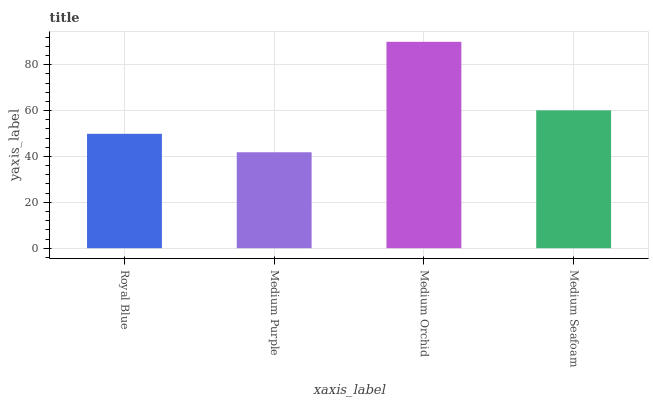Is Medium Purple the minimum?
Answer yes or no. Yes. Is Medium Orchid the maximum?
Answer yes or no. Yes. Is Medium Orchid the minimum?
Answer yes or no. No. Is Medium Purple the maximum?
Answer yes or no. No. Is Medium Orchid greater than Medium Purple?
Answer yes or no. Yes. Is Medium Purple less than Medium Orchid?
Answer yes or no. Yes. Is Medium Purple greater than Medium Orchid?
Answer yes or no. No. Is Medium Orchid less than Medium Purple?
Answer yes or no. No. Is Medium Seafoam the high median?
Answer yes or no. Yes. Is Royal Blue the low median?
Answer yes or no. Yes. Is Royal Blue the high median?
Answer yes or no. No. Is Medium Seafoam the low median?
Answer yes or no. No. 